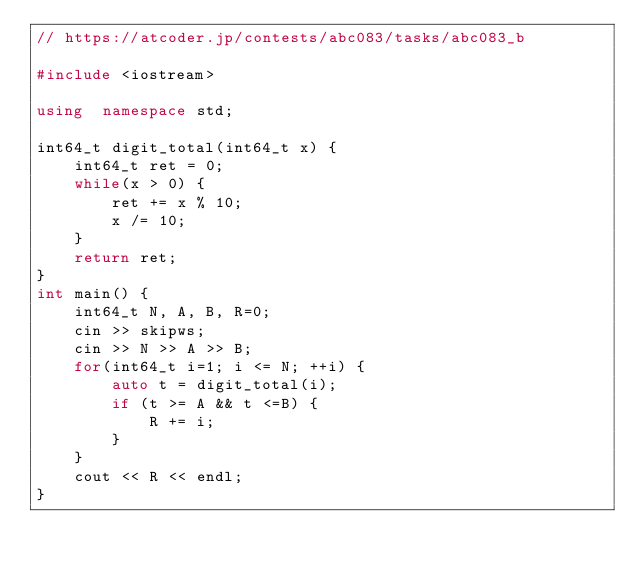Convert code to text. <code><loc_0><loc_0><loc_500><loc_500><_C++_>// https://atcoder.jp/contests/abc083/tasks/abc083_b

#include <iostream>

using  namespace std;

int64_t digit_total(int64_t x) {
    int64_t ret = 0;
    while(x > 0) {
        ret += x % 10;
        x /= 10;
    }
    return ret;
}
int main() {
    int64_t N, A, B, R=0;
    cin >> skipws;
    cin >> N >> A >> B;
    for(int64_t i=1; i <= N; ++i) {
        auto t = digit_total(i);
        if (t >= A && t <=B) {
            R += i;
        }
    }
    cout << R << endl;
}
</code> 